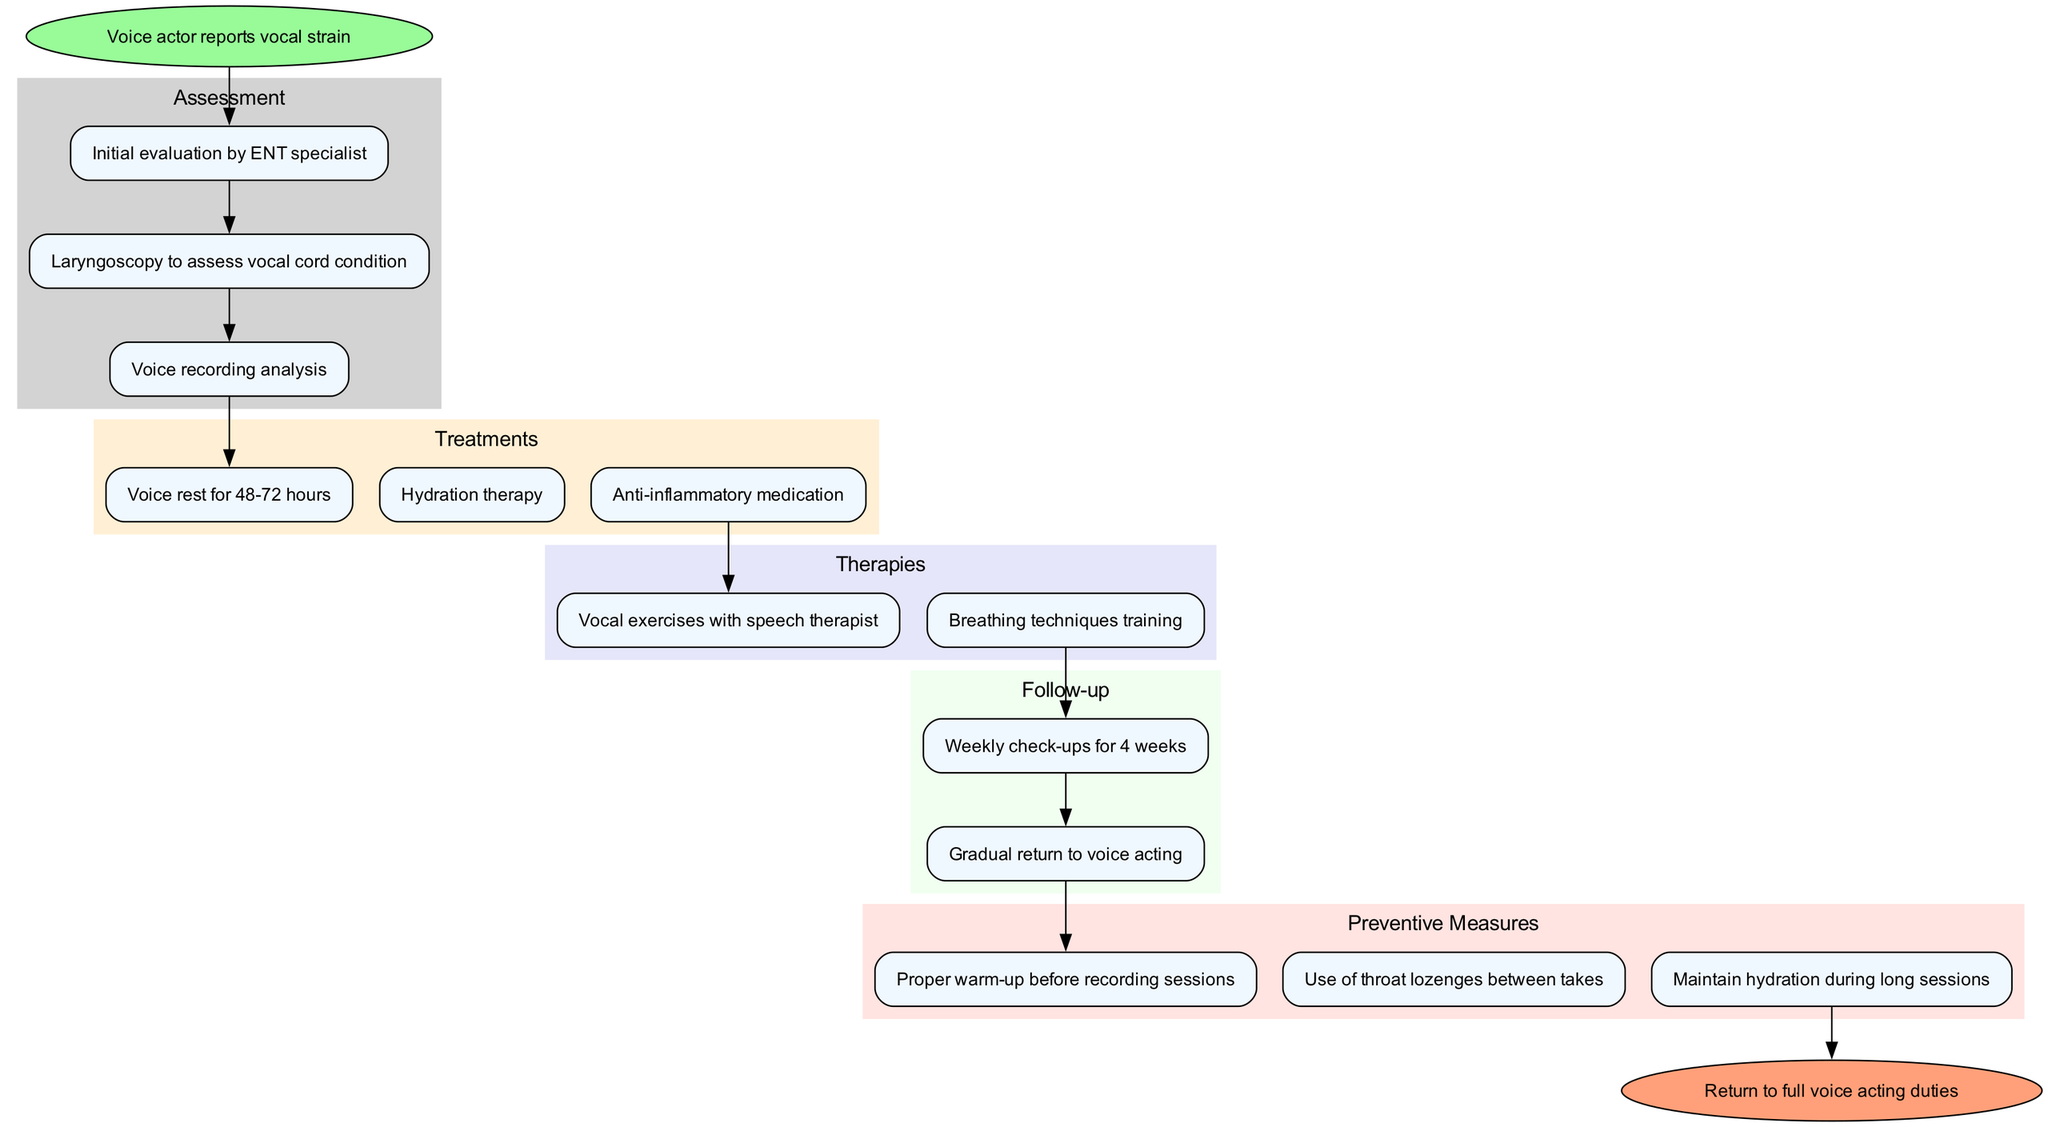What is the first step when a voice actor reports vocal strain? The first step is "Initial evaluation by ENT specialist." This is indicated directly after the start point in the diagram.
Answer: Initial evaluation by ENT specialist How many treatments are listed in the diagram? The treatments section contains three options: "Voice rest for 48-72 hours," "Hydration therapy," and "Anti-inflammatory medication." Counting these gives a total of three treatments.
Answer: 3 What is the endpoint of the clinical pathway? The endpoint is defined as "Return to full voice acting duties," which is the final outcome indicated in the diagram.
Answer: Return to full voice acting duties Which assessment step leads to the treatment options? The treatment options start after the last assessment step, which is "Voice recording analysis." The diagram shows an edge connecting this assessment step to the first treatment step.
Answer: Voice recording analysis What measure is recommended to maintain voice health during long sessions? The preventive measure suggested is "Maintain hydration during long sessions," which is specified in the preventive measures section of the diagram.
Answer: Maintain hydration during long sessions How many follow-up appointments are scheduled in the pathway? The follow-up section specifies "Weekly check-ups for 4 weeks," indicating that four appointments will be scheduled.
Answer: 4 Which therapy is associated with the last treatment option? The last treatment listed is "Anti-inflammatory medication," which connects to "Breathing techniques training" as part of the therapy options in the diagram.
Answer: Breathing techniques training What is the purpose of laryngoscopy in the assessment steps? Laryngoscopy is performed to "assess vocal cord condition," and it is listed as one of the key assessment steps before the treatment phase in the pathway.
Answer: assess vocal cord condition What is the final therapy performed before follow-up appointments? The last therapy is "Breathing techniques training," which directly precedes the follow-up stage in the pathway.
Answer: Breathing techniques training 